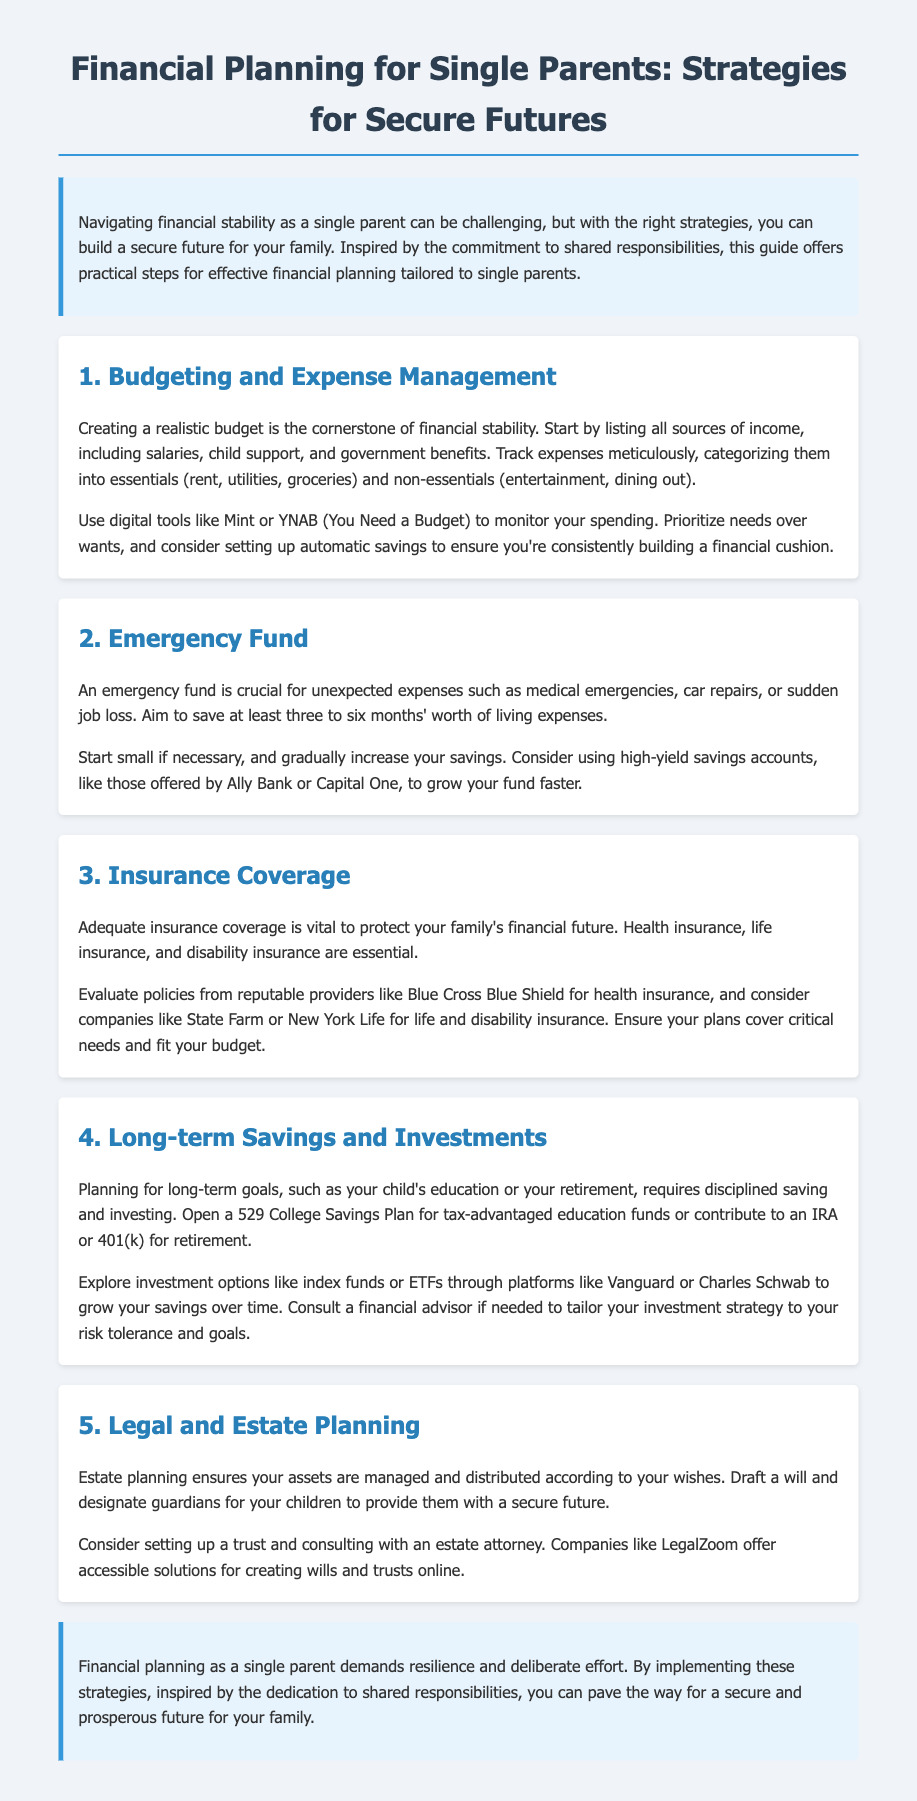What is the cornerstone of financial stability? The cornerstone of financial stability is creating a realistic budget.
Answer: Creating a realistic budget How many months' worth of living expenses should be saved for an emergency fund? The guideline is to save at least three to six months' worth of living expenses.
Answer: Three to six months Which insurance types are considered essential for single parents? Essential insurance types include health insurance, life insurance, and disability insurance.
Answer: Health, life, and disability insurance What kind of savings plan should be opened for education funding? A 529 College Savings Plan should be opened for tax-advantaged education funds.
Answer: 529 College Savings Plan What is the purpose of estate planning mentioned in the document? The purpose of estate planning is to ensure assets are managed and distributed according to wishes.
Answer: Manage and distribute assets What digital tools are recommended for tracking expenses? Recommended digital tools include Mint and YNAB (You Need a Budget).
Answer: Mint and YNAB What action should be taken to ensure consistent savings? Setting up automatic savings should be taken to ensure consistent savings.
Answer: Automatic savings Which platform is suggested for exploring investment options? Vanguard or Charles Schwab is suggested for exploring investment options.
Answer: Vanguard or Charles Schwab What is emphasized as necessary for unexpected expenses? An emergency fund is emphasized as necessary for unexpected expenses.
Answer: Emergency fund 